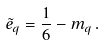<formula> <loc_0><loc_0><loc_500><loc_500>\tilde { e } _ { q } = \frac { 1 } { 6 } - m _ { q } \, .</formula> 